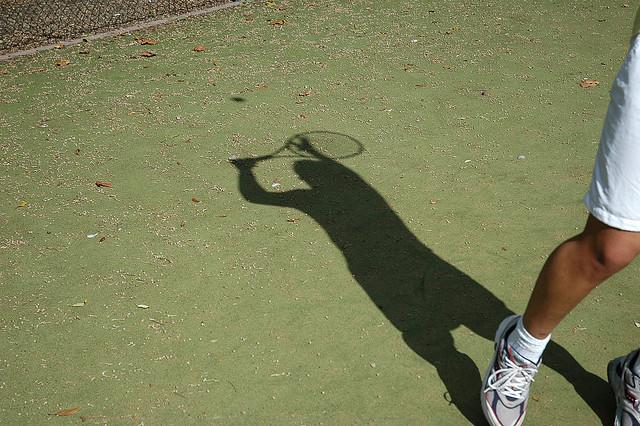What color are the persons shorts?
Quick response, please. White. Is this person kicking up dirt?
Keep it brief. No. What is the shadow depicting?
Quick response, please. Tennis player. There is a shadow, what is it?
Keep it brief. Tennis player. 